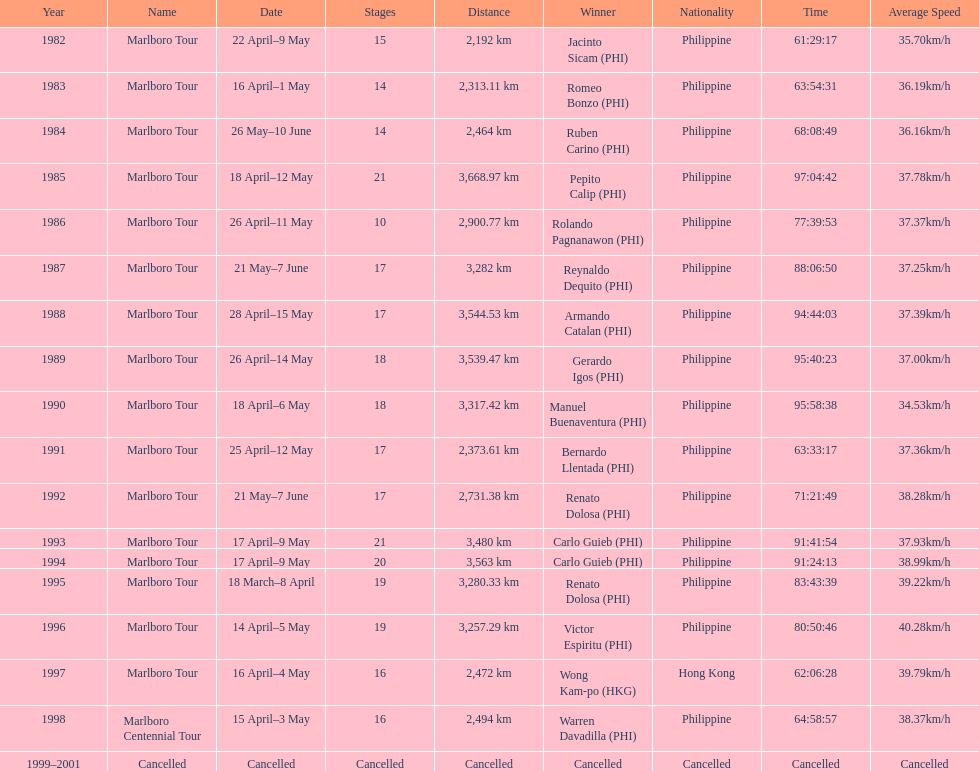What was the largest distance traveled for the marlboro tour? 3,668.97 km. 